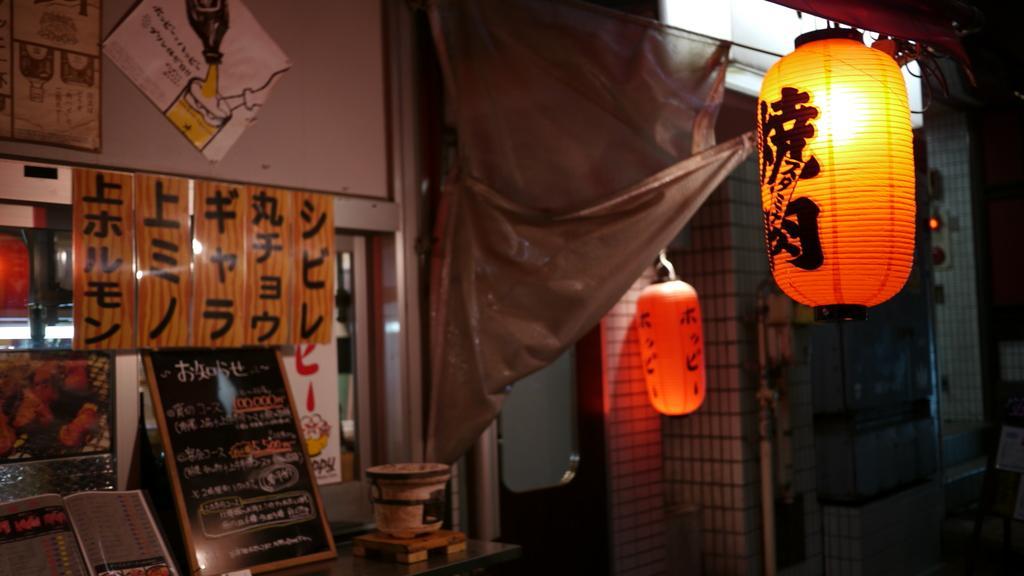Could you give a brief overview of what you see in this image? This picture is an inside view of a room. In this image we can see lamps, grills, curtain, boards, table, bucket, papers, wall, lights. At the top of the image there is a roof. 